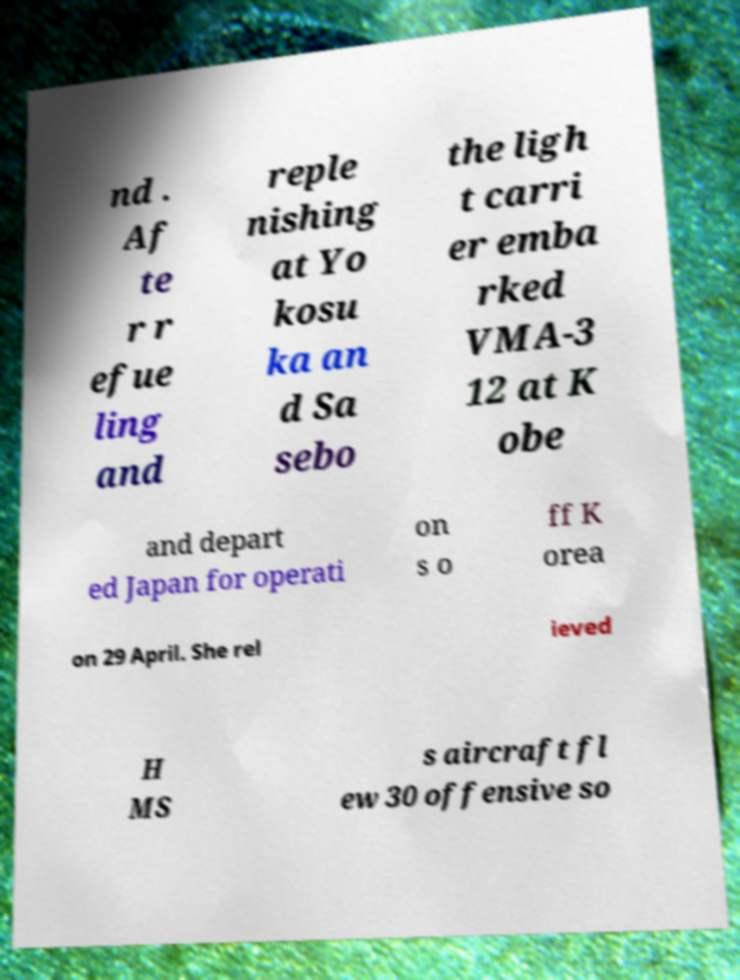For documentation purposes, I need the text within this image transcribed. Could you provide that? nd . Af te r r efue ling and reple nishing at Yo kosu ka an d Sa sebo the ligh t carri er emba rked VMA-3 12 at K obe and depart ed Japan for operati on s o ff K orea on 29 April. She rel ieved H MS s aircraft fl ew 30 offensive so 